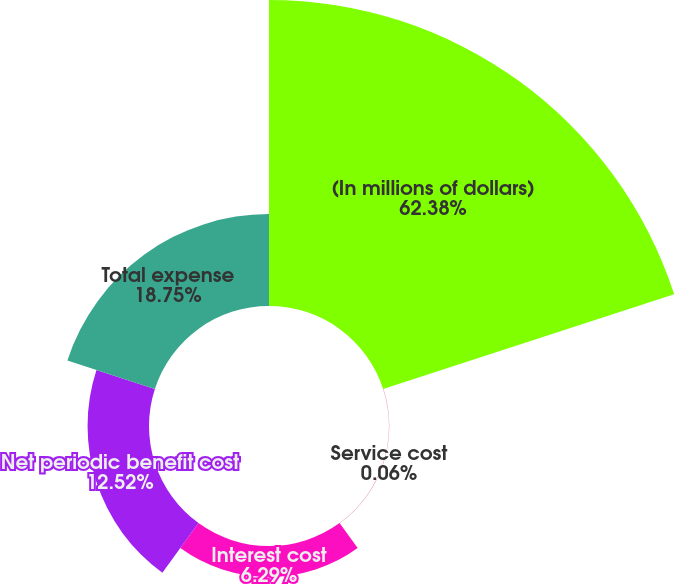<chart> <loc_0><loc_0><loc_500><loc_500><pie_chart><fcel>(In millions of dollars)<fcel>Service cost<fcel>Interest cost<fcel>Net periodic benefit cost<fcel>Total expense<nl><fcel>62.37%<fcel>0.06%<fcel>6.29%<fcel>12.52%<fcel>18.75%<nl></chart> 